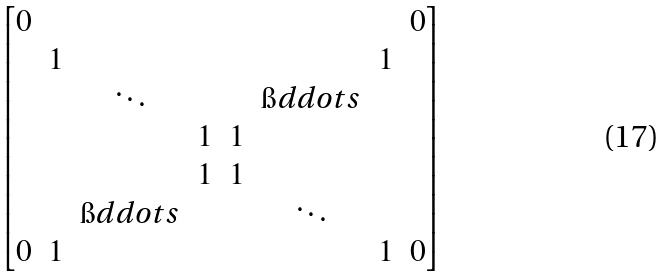<formula> <loc_0><loc_0><loc_500><loc_500>\begin{bmatrix} 0 & & & & & & & 0 \\ & 1 & & & & & 1 & \\ & & \ddots & & & \i d d o t s & & \\ & & & 1 & 1 & & & \\ & & & 1 & 1 & & & \\ & & \i d d o t s & & & \ddots & & \\ 0 & 1 & & & & & 1 & 0 \end{bmatrix}</formula> 